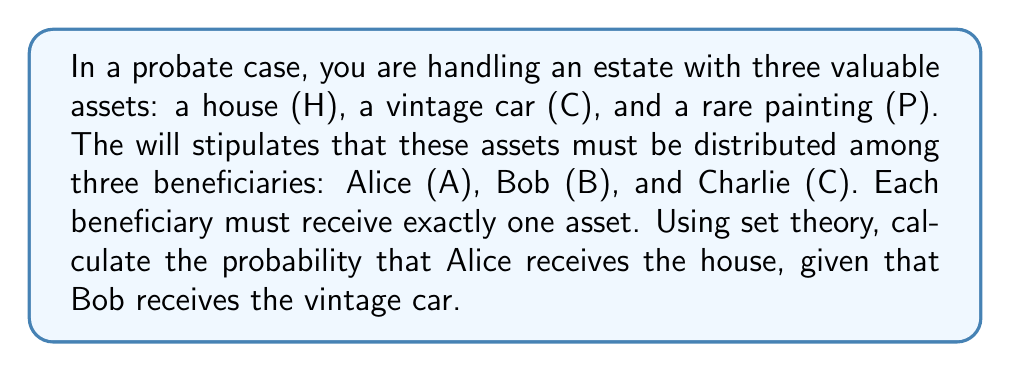Could you help me with this problem? Let's approach this step-by-step using set theory and probability concepts:

1) First, let's define our sample space (S). The sample space consists of all possible distributions of the three assets to the three beneficiaries. We can represent each distribution as an ordered triple (x,y,z), where x, y, and z represent the assets given to Alice, Bob, and Charlie respectively.

   $S = \{(H,C,P), (H,P,C), (C,H,P), (C,P,H), (P,H,C), (P,C,H)\}$

   There are 3! = 6 possible distributions in total.

2) Now, let's define two events:
   A: Alice receives the house
   B: Bob receives the vintage car

3) We need to find P(A|B), the conditional probability of A given B.

4) The formula for conditional probability is:

   $P(A|B) = \frac{P(A \cap B)}{P(B)}$

5) To find P(A ∩ B), we count the number of outcomes where both A and B occur and divide by the total number of outcomes:

   A ∩ B = {(H,C,P)}

   $P(A \cap B) = \frac{1}{6}$

6) To find P(B), we count the number of outcomes where B occurs and divide by the total number of outcomes:

   B = {(H,C,P), (P,C,H)}

   $P(B) = \frac{2}{6} = \frac{1}{3}$

7) Now we can calculate P(A|B):

   $P(A|B) = \frac{P(A \cap B)}{P(B)} = \frac{1/6}{1/3} = \frac{1}{2}$

Therefore, the probability that Alice receives the house, given that Bob receives the vintage car, is 1/2 or 50%.
Answer: $\frac{1}{2}$ or 0.5 or 50% 